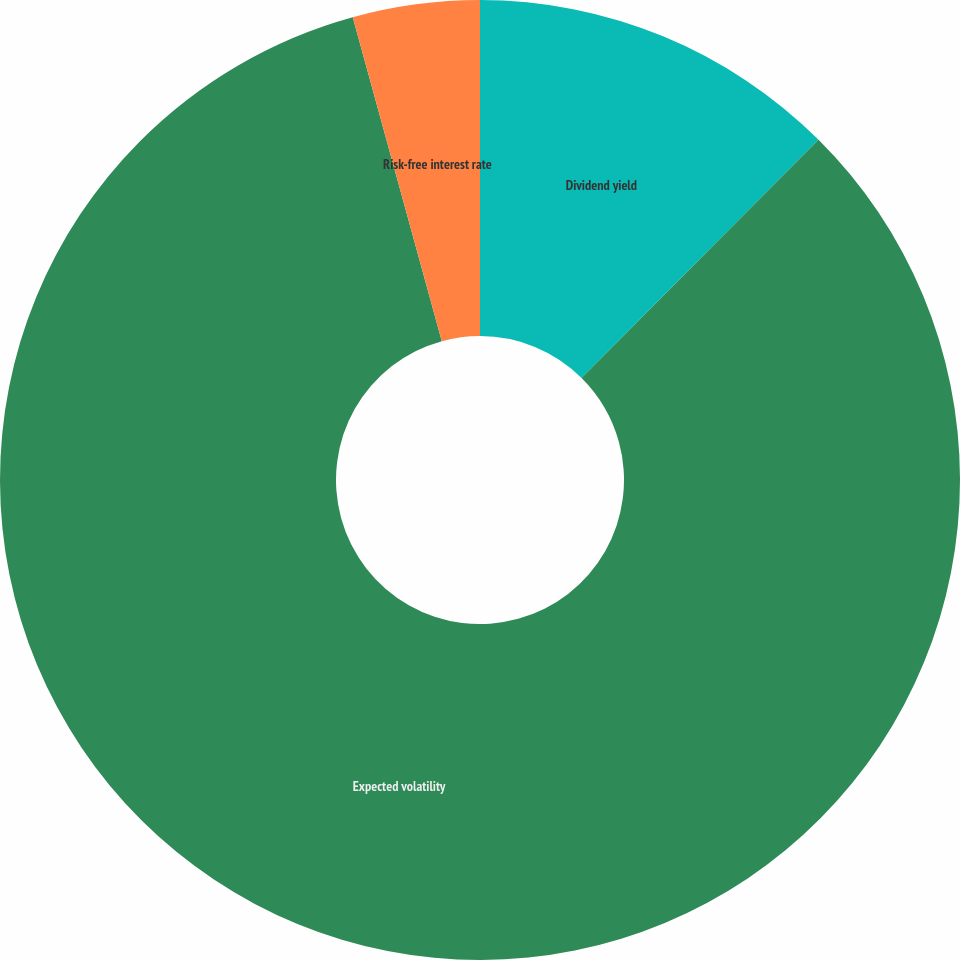Convert chart to OTSL. <chart><loc_0><loc_0><loc_500><loc_500><pie_chart><fcel>Dividend yield<fcel>Expected volatility<fcel>Risk-free interest rate<nl><fcel>12.46%<fcel>83.27%<fcel>4.27%<nl></chart> 